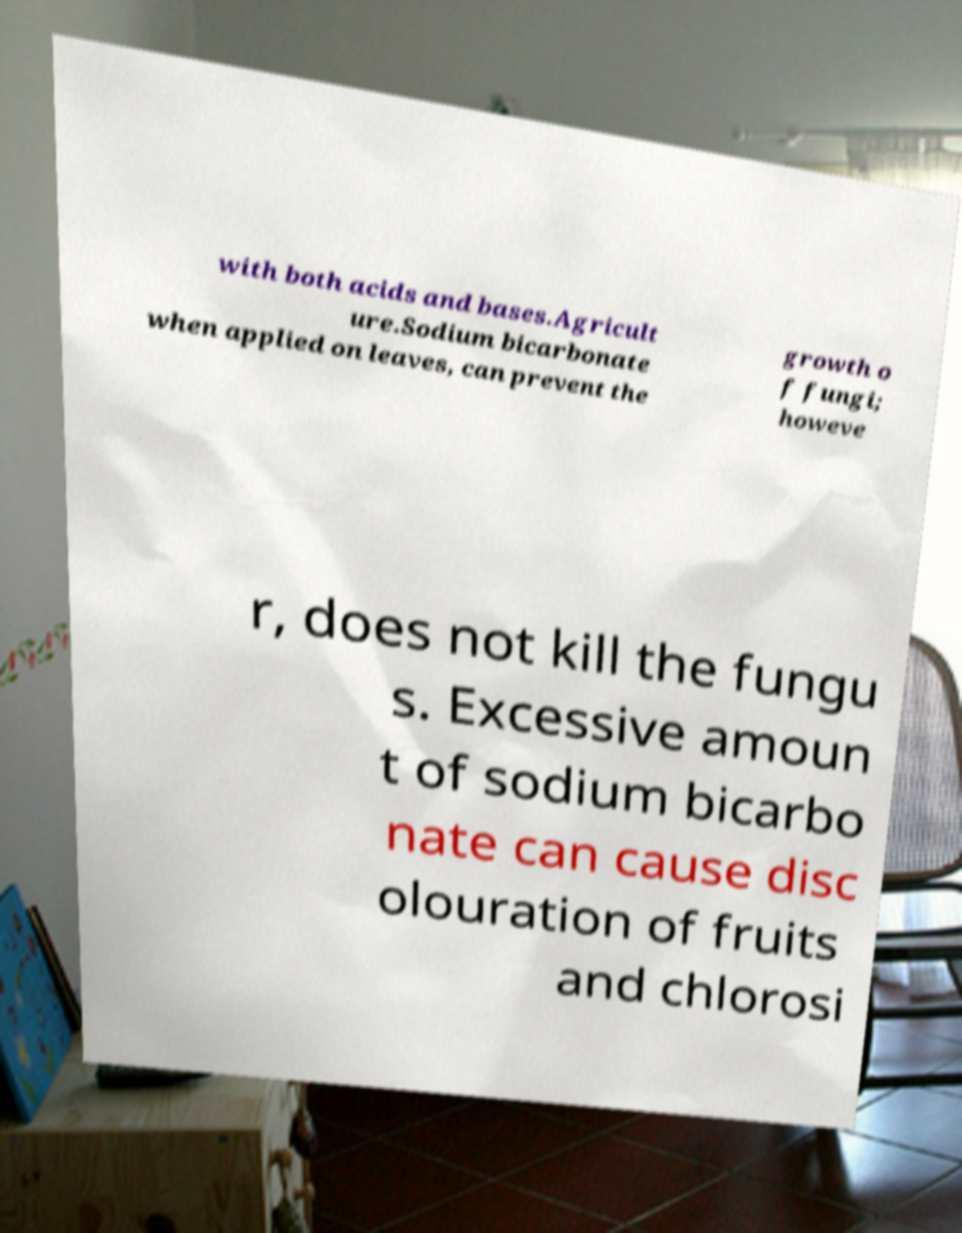Could you extract and type out the text from this image? with both acids and bases.Agricult ure.Sodium bicarbonate when applied on leaves, can prevent the growth o f fungi; howeve r, does not kill the fungu s. Excessive amoun t of sodium bicarbo nate can cause disc olouration of fruits and chlorosi 